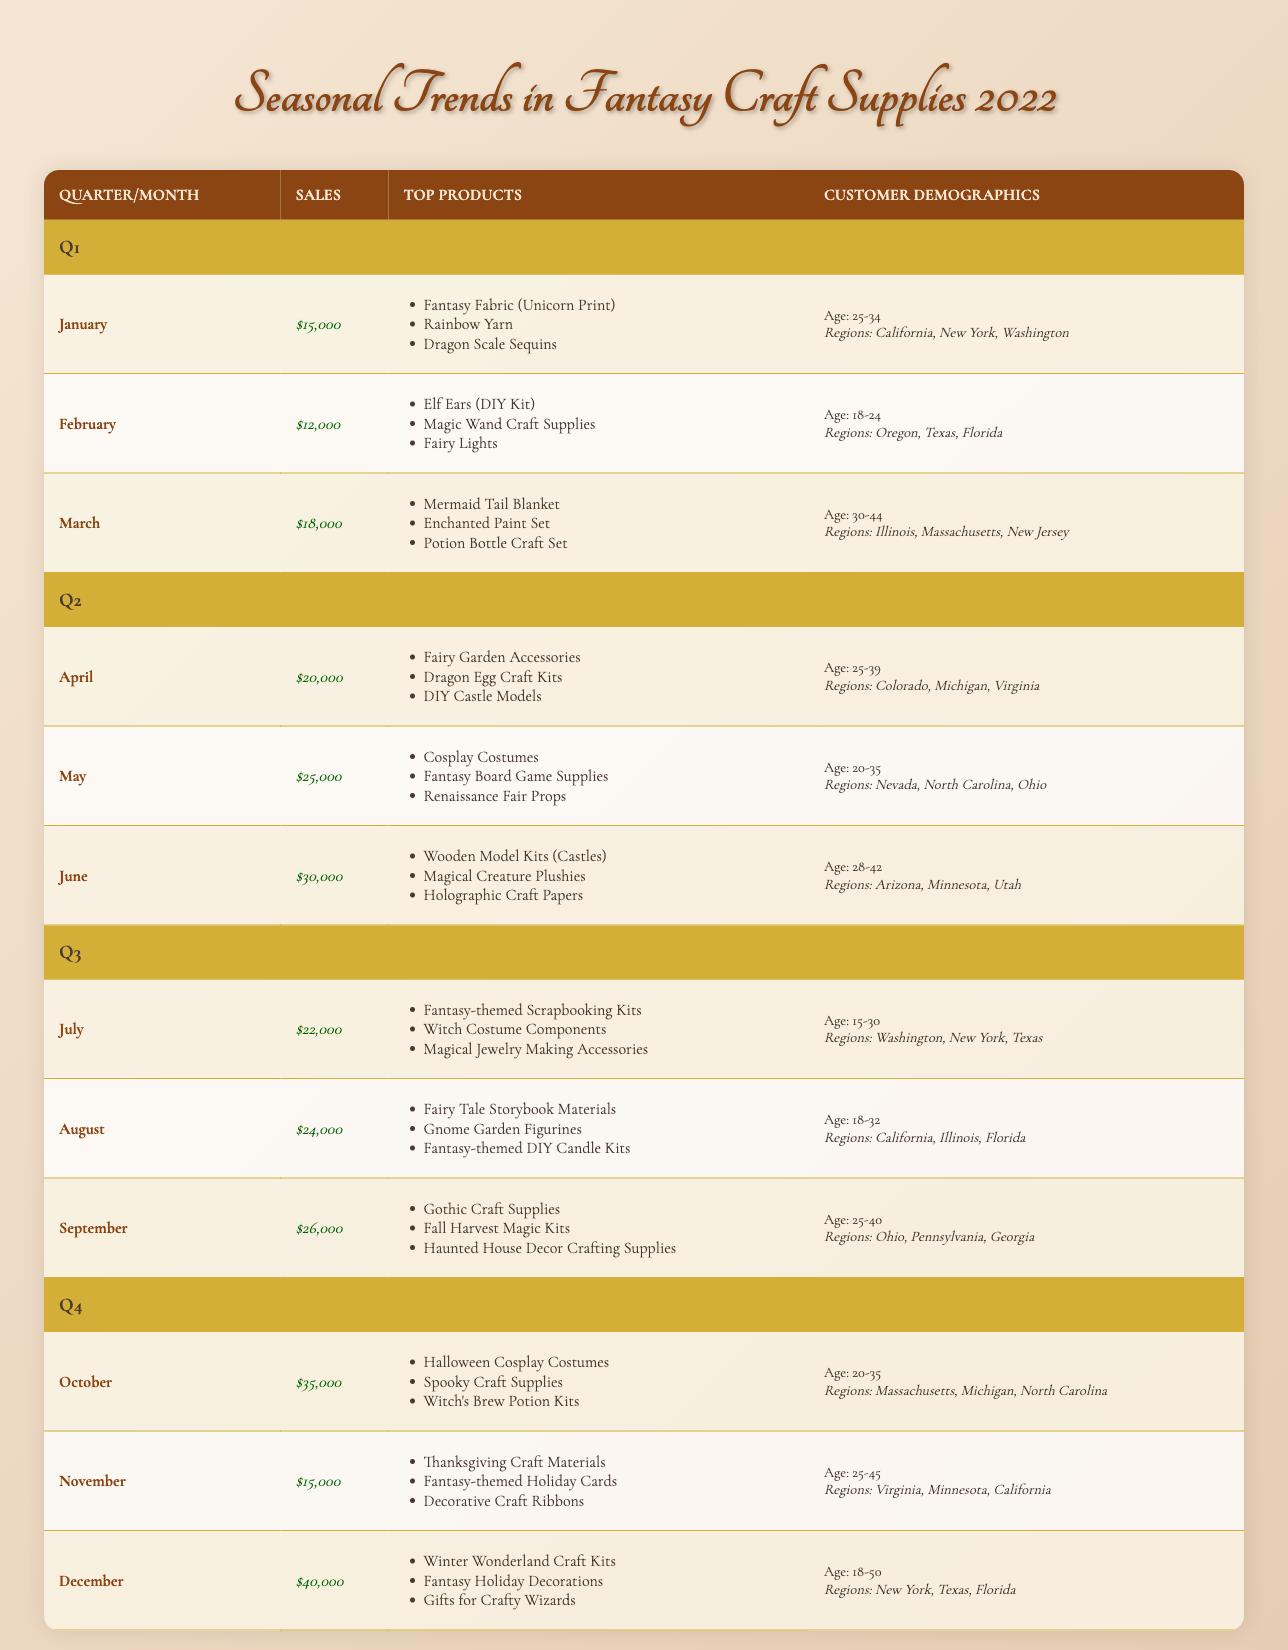What were the total sales in Q2? To find the total sales in Q2, I need to sum the sales from April, May, and June: $20,000 + $25,000 + $30,000 = $75,000.
Answer: $75,000 Which month had the highest sales in Q1? Among January, February, and March, the sales are: January - $15,000, February - $12,000, and March - $18,000. March has the highest sales with $18,000.
Answer: March Did sales increase from August to September? August had sales of $24,000 and September had sales of $26,000. Since $26,000 is greater than $24,000, the sales did increase.
Answer: Yes What is the average sales amount for Q4? I will add the sales for October, November, and December: October - $35,000, November - $15,000, December - $40,000. Sum: $35,000 + $15,000 + $40,000 = $90,000. There are 3 months, so the average is $90,000 divided by 3, which equals $30,000.
Answer: $30,000 Which regions were popular in March? The customer demographics for March indicate the popular regions were Illinois, Massachusetts, and New Jersey.
Answer: Illinois, Massachusetts, New Jersey How many top products were listed for sales in July? In July, the top products listed were: Fantasy-themed Scrapbooking Kits, Witch Costume Components, and Magical Jewelry Making Accessories. That makes a total of 3 top products.
Answer: 3 What was the sales difference between December and February? December sales were $40,000 and February sales were $12,000. To find the difference, subtract February from December: $40,000 - $12,000 = $28,000.
Answer: $28,000 Are there more regions popular in the first quarter than in the second quarter? In Q1, the popular regions sum up to 3 (California, New York, Washington in January; Oregon, Texas, Florida in February; Illinois, Massachusetts, New Jersey in March). In Q2, the popular regions are also 3 (Colorado, Michigan, Virginia in April; Nevada, North Carolina, Ohio in May; Arizona, Minnesota, Utah in June). Therefore, the numbers are equal.
Answer: No Which age group was most active in purchasing craft supplies in June? For June, the customer demographics indicate the age range was 28-42 years old. This is the age group listed for June.
Answer: 28-42 